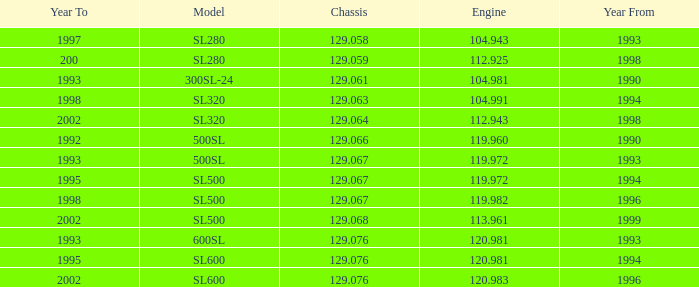Which Engine has a Model of sl500, and a Year From larger than 1999? None. 